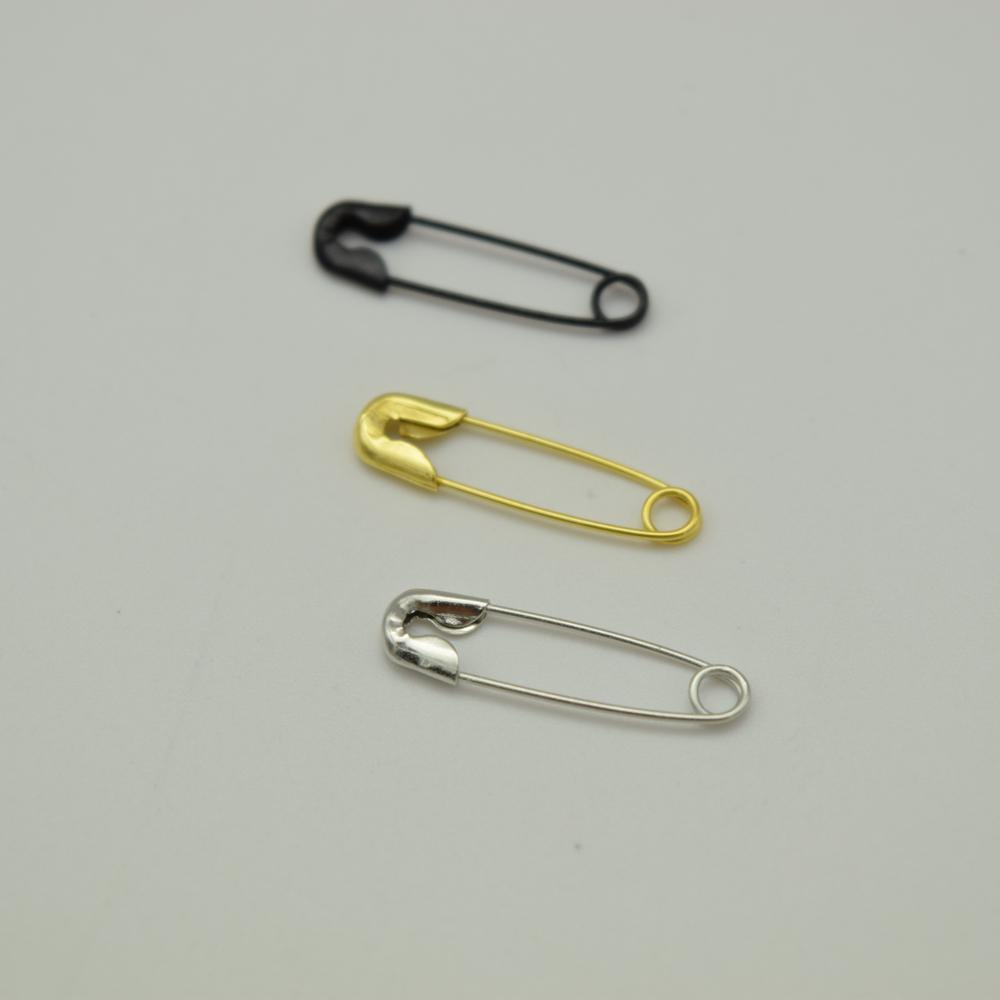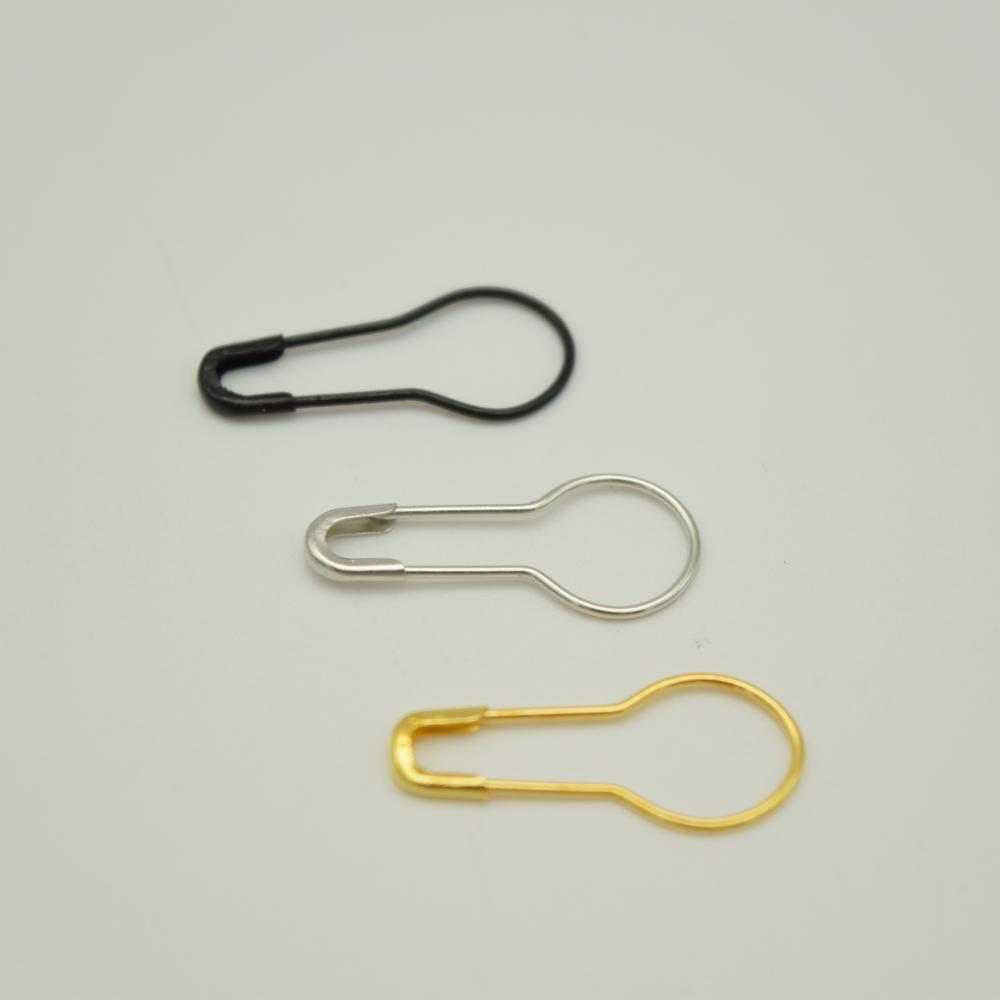The first image is the image on the left, the second image is the image on the right. Examine the images to the left and right. Is the description "There are more pins in the image on the right than in the image on the left." accurate? Answer yes or no. No. The first image is the image on the left, the second image is the image on the right. Evaluate the accuracy of this statement regarding the images: "All pins in each image are the same color and all have a large circular end opposite the clasp end.". Is it true? Answer yes or no. No. 